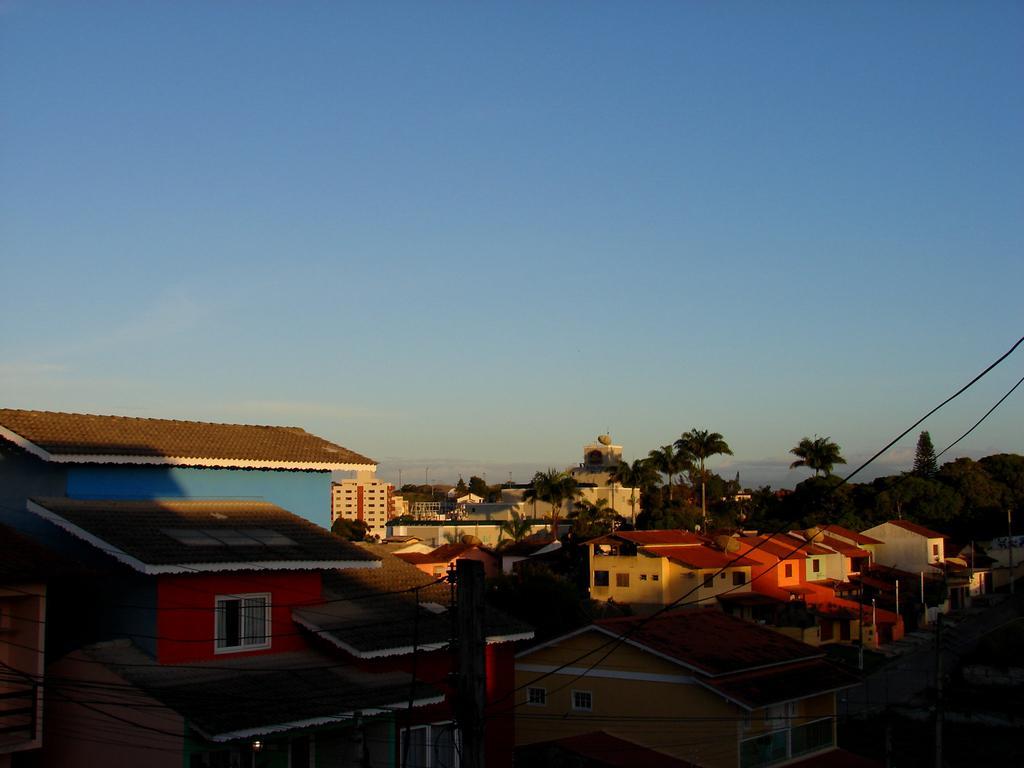Could you give a brief overview of what you see in this image? Here we can see houses, trees, poles, and wires. In the background there is sky. 